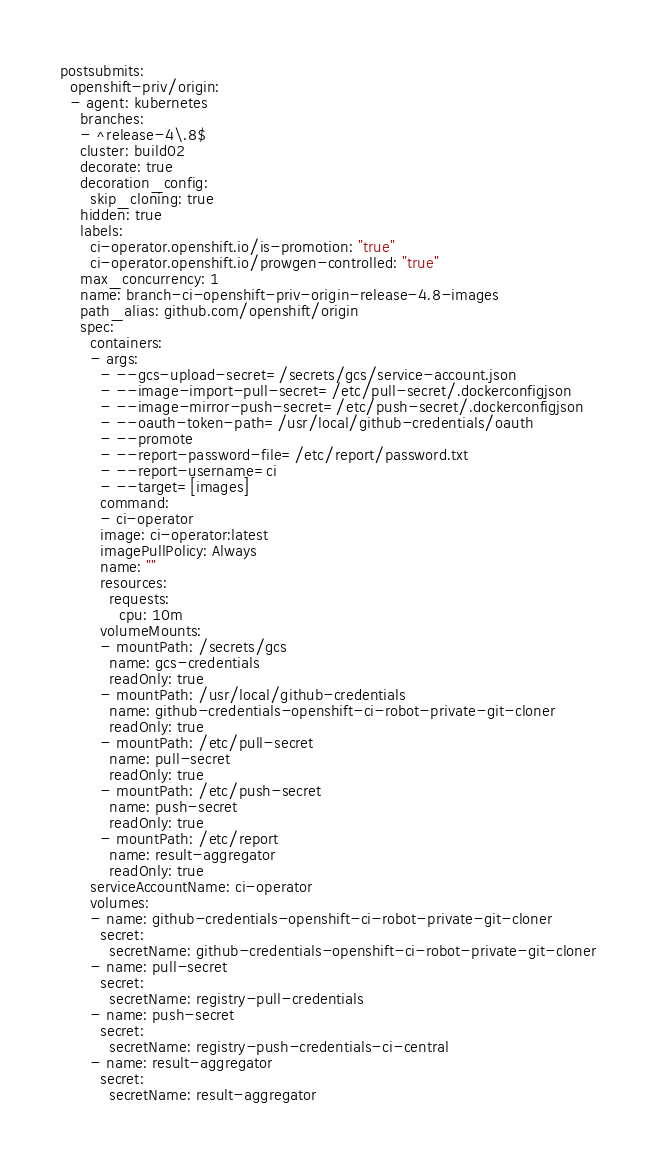Convert code to text. <code><loc_0><loc_0><loc_500><loc_500><_YAML_>postsubmits:
  openshift-priv/origin:
  - agent: kubernetes
    branches:
    - ^release-4\.8$
    cluster: build02
    decorate: true
    decoration_config:
      skip_cloning: true
    hidden: true
    labels:
      ci-operator.openshift.io/is-promotion: "true"
      ci-operator.openshift.io/prowgen-controlled: "true"
    max_concurrency: 1
    name: branch-ci-openshift-priv-origin-release-4.8-images
    path_alias: github.com/openshift/origin
    spec:
      containers:
      - args:
        - --gcs-upload-secret=/secrets/gcs/service-account.json
        - --image-import-pull-secret=/etc/pull-secret/.dockerconfigjson
        - --image-mirror-push-secret=/etc/push-secret/.dockerconfigjson
        - --oauth-token-path=/usr/local/github-credentials/oauth
        - --promote
        - --report-password-file=/etc/report/password.txt
        - --report-username=ci
        - --target=[images]
        command:
        - ci-operator
        image: ci-operator:latest
        imagePullPolicy: Always
        name: ""
        resources:
          requests:
            cpu: 10m
        volumeMounts:
        - mountPath: /secrets/gcs
          name: gcs-credentials
          readOnly: true
        - mountPath: /usr/local/github-credentials
          name: github-credentials-openshift-ci-robot-private-git-cloner
          readOnly: true
        - mountPath: /etc/pull-secret
          name: pull-secret
          readOnly: true
        - mountPath: /etc/push-secret
          name: push-secret
          readOnly: true
        - mountPath: /etc/report
          name: result-aggregator
          readOnly: true
      serviceAccountName: ci-operator
      volumes:
      - name: github-credentials-openshift-ci-robot-private-git-cloner
        secret:
          secretName: github-credentials-openshift-ci-robot-private-git-cloner
      - name: pull-secret
        secret:
          secretName: registry-pull-credentials
      - name: push-secret
        secret:
          secretName: registry-push-credentials-ci-central
      - name: result-aggregator
        secret:
          secretName: result-aggregator
</code> 